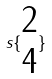<formula> <loc_0><loc_0><loc_500><loc_500>s \{ \begin{matrix} 2 \\ 4 \end{matrix} \}</formula> 